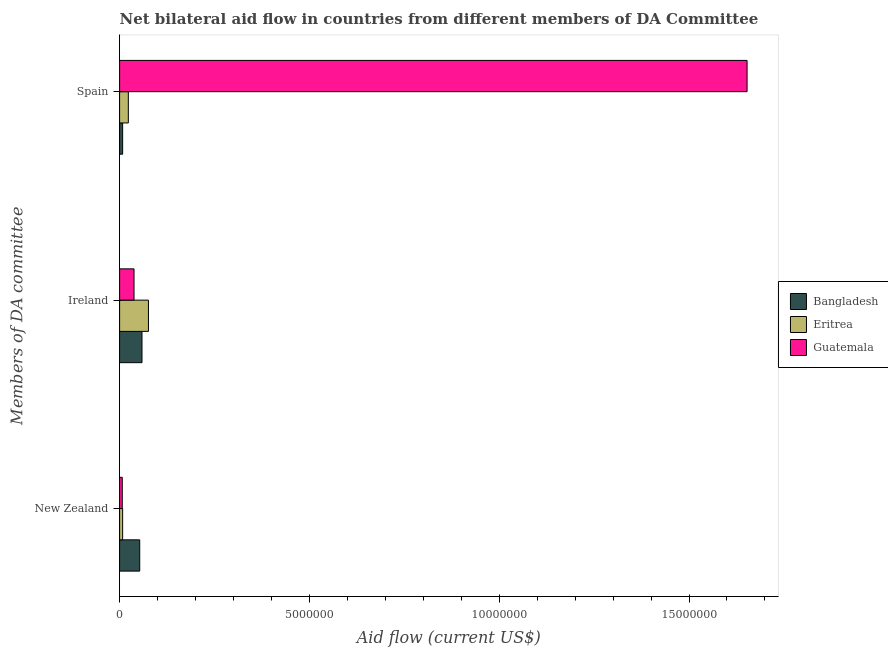How many different coloured bars are there?
Keep it short and to the point. 3. How many groups of bars are there?
Give a very brief answer. 3. How many bars are there on the 1st tick from the top?
Provide a succinct answer. 3. What is the label of the 2nd group of bars from the top?
Offer a very short reply. Ireland. What is the amount of aid provided by spain in Eritrea?
Your answer should be compact. 2.30e+05. Across all countries, what is the maximum amount of aid provided by ireland?
Keep it short and to the point. 7.60e+05. Across all countries, what is the minimum amount of aid provided by new zealand?
Offer a terse response. 7.00e+04. In which country was the amount of aid provided by ireland maximum?
Offer a very short reply. Eritrea. In which country was the amount of aid provided by ireland minimum?
Ensure brevity in your answer.  Guatemala. What is the total amount of aid provided by ireland in the graph?
Your answer should be very brief. 1.73e+06. What is the difference between the amount of aid provided by ireland in Bangladesh and that in Guatemala?
Offer a terse response. 2.10e+05. What is the difference between the amount of aid provided by spain in Guatemala and the amount of aid provided by new zealand in Bangladesh?
Your answer should be compact. 1.60e+07. What is the average amount of aid provided by new zealand per country?
Make the answer very short. 2.27e+05. What is the difference between the amount of aid provided by new zealand and amount of aid provided by ireland in Eritrea?
Give a very brief answer. -6.80e+05. What is the ratio of the amount of aid provided by ireland in Bangladesh to that in Eritrea?
Offer a very short reply. 0.78. Is the amount of aid provided by ireland in Eritrea less than that in Bangladesh?
Provide a short and direct response. No. Is the difference between the amount of aid provided by new zealand in Eritrea and Guatemala greater than the difference between the amount of aid provided by ireland in Eritrea and Guatemala?
Your answer should be compact. No. What is the difference between the highest and the second highest amount of aid provided by ireland?
Offer a terse response. 1.70e+05. What is the difference between the highest and the lowest amount of aid provided by new zealand?
Your answer should be compact. 4.60e+05. In how many countries, is the amount of aid provided by new zealand greater than the average amount of aid provided by new zealand taken over all countries?
Your answer should be very brief. 1. How many bars are there?
Give a very brief answer. 9. How many countries are there in the graph?
Give a very brief answer. 3. Where does the legend appear in the graph?
Offer a terse response. Center right. How many legend labels are there?
Offer a terse response. 3. What is the title of the graph?
Ensure brevity in your answer.  Net bilateral aid flow in countries from different members of DA Committee. Does "Algeria" appear as one of the legend labels in the graph?
Ensure brevity in your answer.  No. What is the label or title of the Y-axis?
Offer a very short reply. Members of DA committee. What is the Aid flow (current US$) in Bangladesh in New Zealand?
Offer a very short reply. 5.30e+05. What is the Aid flow (current US$) of Guatemala in New Zealand?
Provide a succinct answer. 7.00e+04. What is the Aid flow (current US$) in Bangladesh in Ireland?
Your answer should be very brief. 5.90e+05. What is the Aid flow (current US$) of Eritrea in Ireland?
Provide a succinct answer. 7.60e+05. What is the Aid flow (current US$) in Guatemala in Ireland?
Your response must be concise. 3.80e+05. What is the Aid flow (current US$) in Eritrea in Spain?
Ensure brevity in your answer.  2.30e+05. What is the Aid flow (current US$) of Guatemala in Spain?
Provide a short and direct response. 1.65e+07. Across all Members of DA committee, what is the maximum Aid flow (current US$) of Bangladesh?
Give a very brief answer. 5.90e+05. Across all Members of DA committee, what is the maximum Aid flow (current US$) of Eritrea?
Your answer should be very brief. 7.60e+05. Across all Members of DA committee, what is the maximum Aid flow (current US$) in Guatemala?
Make the answer very short. 1.65e+07. Across all Members of DA committee, what is the minimum Aid flow (current US$) in Eritrea?
Give a very brief answer. 8.00e+04. What is the total Aid flow (current US$) in Bangladesh in the graph?
Your response must be concise. 1.20e+06. What is the total Aid flow (current US$) of Eritrea in the graph?
Provide a short and direct response. 1.07e+06. What is the total Aid flow (current US$) in Guatemala in the graph?
Give a very brief answer. 1.70e+07. What is the difference between the Aid flow (current US$) of Eritrea in New Zealand and that in Ireland?
Provide a succinct answer. -6.80e+05. What is the difference between the Aid flow (current US$) in Guatemala in New Zealand and that in Ireland?
Your answer should be compact. -3.10e+05. What is the difference between the Aid flow (current US$) of Bangladesh in New Zealand and that in Spain?
Give a very brief answer. 4.50e+05. What is the difference between the Aid flow (current US$) in Eritrea in New Zealand and that in Spain?
Make the answer very short. -1.50e+05. What is the difference between the Aid flow (current US$) of Guatemala in New Zealand and that in Spain?
Offer a very short reply. -1.65e+07. What is the difference between the Aid flow (current US$) of Bangladesh in Ireland and that in Spain?
Make the answer very short. 5.10e+05. What is the difference between the Aid flow (current US$) of Eritrea in Ireland and that in Spain?
Provide a succinct answer. 5.30e+05. What is the difference between the Aid flow (current US$) of Guatemala in Ireland and that in Spain?
Make the answer very short. -1.62e+07. What is the difference between the Aid flow (current US$) in Bangladesh in New Zealand and the Aid flow (current US$) in Eritrea in Ireland?
Provide a succinct answer. -2.30e+05. What is the difference between the Aid flow (current US$) in Bangladesh in New Zealand and the Aid flow (current US$) in Guatemala in Ireland?
Keep it short and to the point. 1.50e+05. What is the difference between the Aid flow (current US$) in Eritrea in New Zealand and the Aid flow (current US$) in Guatemala in Ireland?
Ensure brevity in your answer.  -3.00e+05. What is the difference between the Aid flow (current US$) in Bangladesh in New Zealand and the Aid flow (current US$) in Eritrea in Spain?
Provide a succinct answer. 3.00e+05. What is the difference between the Aid flow (current US$) in Bangladesh in New Zealand and the Aid flow (current US$) in Guatemala in Spain?
Your response must be concise. -1.60e+07. What is the difference between the Aid flow (current US$) of Eritrea in New Zealand and the Aid flow (current US$) of Guatemala in Spain?
Ensure brevity in your answer.  -1.64e+07. What is the difference between the Aid flow (current US$) in Bangladesh in Ireland and the Aid flow (current US$) in Eritrea in Spain?
Ensure brevity in your answer.  3.60e+05. What is the difference between the Aid flow (current US$) in Bangladesh in Ireland and the Aid flow (current US$) in Guatemala in Spain?
Offer a terse response. -1.59e+07. What is the difference between the Aid flow (current US$) of Eritrea in Ireland and the Aid flow (current US$) of Guatemala in Spain?
Provide a succinct answer. -1.58e+07. What is the average Aid flow (current US$) of Eritrea per Members of DA committee?
Ensure brevity in your answer.  3.57e+05. What is the average Aid flow (current US$) in Guatemala per Members of DA committee?
Offer a terse response. 5.66e+06. What is the difference between the Aid flow (current US$) of Bangladesh and Aid flow (current US$) of Guatemala in New Zealand?
Keep it short and to the point. 4.60e+05. What is the difference between the Aid flow (current US$) in Bangladesh and Aid flow (current US$) in Eritrea in Ireland?
Offer a very short reply. -1.70e+05. What is the difference between the Aid flow (current US$) of Bangladesh and Aid flow (current US$) of Guatemala in Ireland?
Provide a succinct answer. 2.10e+05. What is the difference between the Aid flow (current US$) in Bangladesh and Aid flow (current US$) in Guatemala in Spain?
Give a very brief answer. -1.64e+07. What is the difference between the Aid flow (current US$) in Eritrea and Aid flow (current US$) in Guatemala in Spain?
Your response must be concise. -1.63e+07. What is the ratio of the Aid flow (current US$) in Bangladesh in New Zealand to that in Ireland?
Keep it short and to the point. 0.9. What is the ratio of the Aid flow (current US$) in Eritrea in New Zealand to that in Ireland?
Provide a succinct answer. 0.11. What is the ratio of the Aid flow (current US$) in Guatemala in New Zealand to that in Ireland?
Your answer should be compact. 0.18. What is the ratio of the Aid flow (current US$) of Bangladesh in New Zealand to that in Spain?
Provide a succinct answer. 6.62. What is the ratio of the Aid flow (current US$) in Eritrea in New Zealand to that in Spain?
Your answer should be very brief. 0.35. What is the ratio of the Aid flow (current US$) in Guatemala in New Zealand to that in Spain?
Offer a very short reply. 0. What is the ratio of the Aid flow (current US$) in Bangladesh in Ireland to that in Spain?
Your response must be concise. 7.38. What is the ratio of the Aid flow (current US$) in Eritrea in Ireland to that in Spain?
Provide a short and direct response. 3.3. What is the ratio of the Aid flow (current US$) of Guatemala in Ireland to that in Spain?
Offer a very short reply. 0.02. What is the difference between the highest and the second highest Aid flow (current US$) in Eritrea?
Give a very brief answer. 5.30e+05. What is the difference between the highest and the second highest Aid flow (current US$) in Guatemala?
Provide a succinct answer. 1.62e+07. What is the difference between the highest and the lowest Aid flow (current US$) in Bangladesh?
Offer a very short reply. 5.10e+05. What is the difference between the highest and the lowest Aid flow (current US$) in Eritrea?
Provide a succinct answer. 6.80e+05. What is the difference between the highest and the lowest Aid flow (current US$) of Guatemala?
Provide a succinct answer. 1.65e+07. 